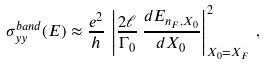<formula> <loc_0><loc_0><loc_500><loc_500>\sigma _ { y y } ^ { b a n d } ( E ) \approx \frac { e ^ { 2 } } { h } \, \left | \frac { 2 \ell } { \Gamma _ { 0 } } \, \frac { d E _ { n _ { F } , X _ { 0 } } } { d X _ { 0 } } \right | ^ { 2 } _ { X _ { 0 } = X _ { F } } \, ,</formula> 